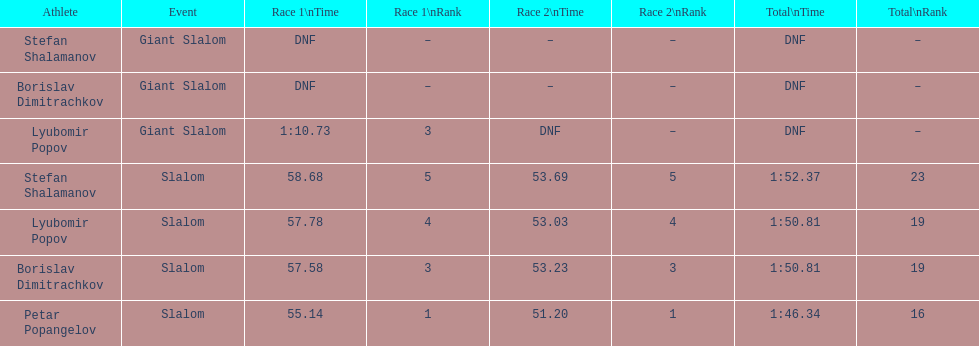What is the difference in time for petar popangelov in race 1and 2 3.94. 